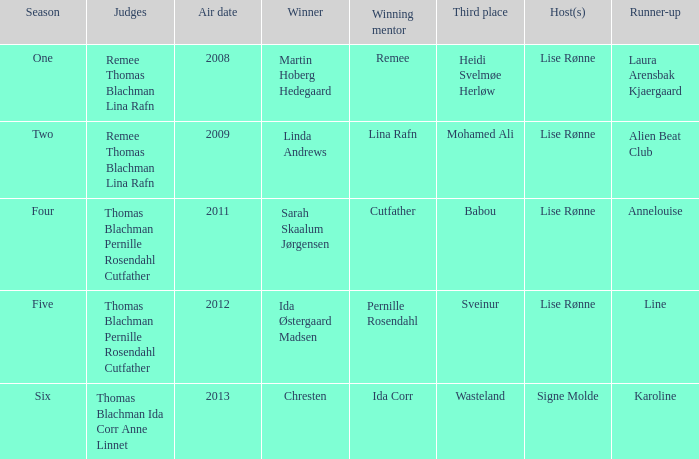Who won third place in season four? Babou. 